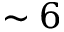<formula> <loc_0><loc_0><loc_500><loc_500>\sim 6</formula> 